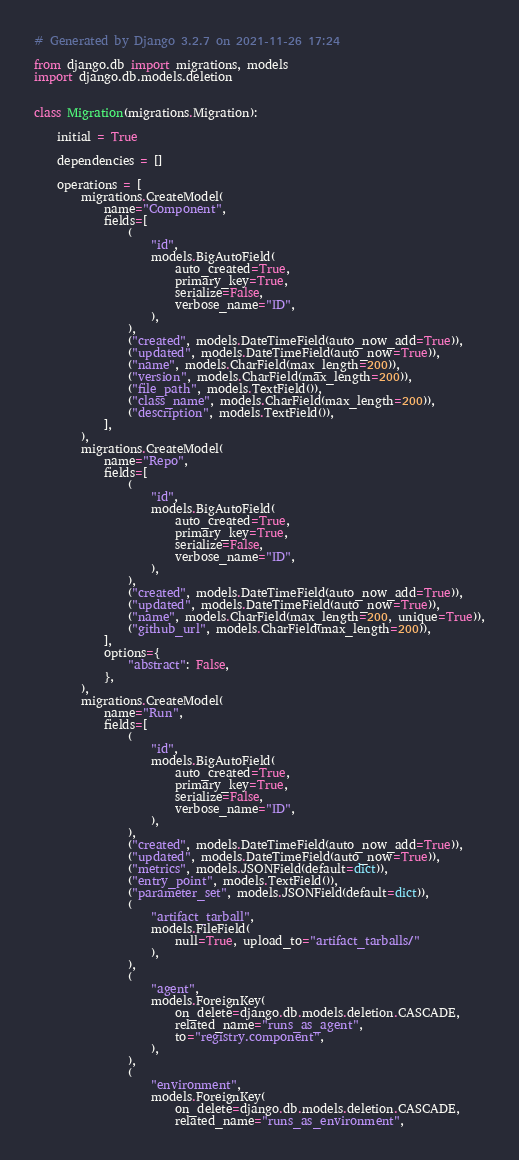<code> <loc_0><loc_0><loc_500><loc_500><_Python_># Generated by Django 3.2.7 on 2021-11-26 17:24

from django.db import migrations, models
import django.db.models.deletion


class Migration(migrations.Migration):

    initial = True

    dependencies = []

    operations = [
        migrations.CreateModel(
            name="Component",
            fields=[
                (
                    "id",
                    models.BigAutoField(
                        auto_created=True,
                        primary_key=True,
                        serialize=False,
                        verbose_name="ID",
                    ),
                ),
                ("created", models.DateTimeField(auto_now_add=True)),
                ("updated", models.DateTimeField(auto_now=True)),
                ("name", models.CharField(max_length=200)),
                ("version", models.CharField(max_length=200)),
                ("file_path", models.TextField()),
                ("class_name", models.CharField(max_length=200)),
                ("description", models.TextField()),
            ],
        ),
        migrations.CreateModel(
            name="Repo",
            fields=[
                (
                    "id",
                    models.BigAutoField(
                        auto_created=True,
                        primary_key=True,
                        serialize=False,
                        verbose_name="ID",
                    ),
                ),
                ("created", models.DateTimeField(auto_now_add=True)),
                ("updated", models.DateTimeField(auto_now=True)),
                ("name", models.CharField(max_length=200, unique=True)),
                ("github_url", models.CharField(max_length=200)),
            ],
            options={
                "abstract": False,
            },
        ),
        migrations.CreateModel(
            name="Run",
            fields=[
                (
                    "id",
                    models.BigAutoField(
                        auto_created=True,
                        primary_key=True,
                        serialize=False,
                        verbose_name="ID",
                    ),
                ),
                ("created", models.DateTimeField(auto_now_add=True)),
                ("updated", models.DateTimeField(auto_now=True)),
                ("metrics", models.JSONField(default=dict)),
                ("entry_point", models.TextField()),
                ("parameter_set", models.JSONField(default=dict)),
                (
                    "artifact_tarball",
                    models.FileField(
                        null=True, upload_to="artifact_tarballs/"
                    ),
                ),
                (
                    "agent",
                    models.ForeignKey(
                        on_delete=django.db.models.deletion.CASCADE,
                        related_name="runs_as_agent",
                        to="registry.component",
                    ),
                ),
                (
                    "environment",
                    models.ForeignKey(
                        on_delete=django.db.models.deletion.CASCADE,
                        related_name="runs_as_environment",</code> 